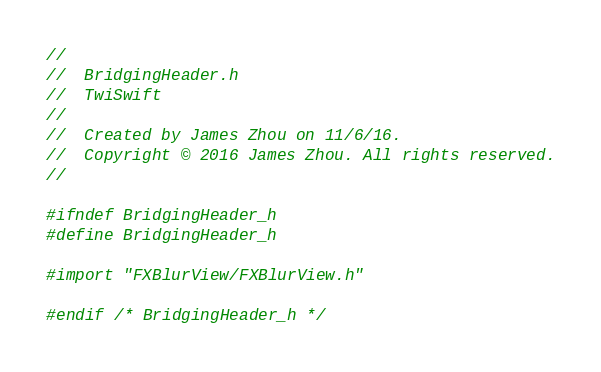<code> <loc_0><loc_0><loc_500><loc_500><_C_>//
//  BridgingHeader.h
//  TwiSwift
//
//  Created by James Zhou on 11/6/16.
//  Copyright © 2016 James Zhou. All rights reserved.
//

#ifndef BridgingHeader_h
#define BridgingHeader_h

#import "FXBlurView/FXBlurView.h"

#endif /* BridgingHeader_h */
</code> 